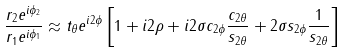Convert formula to latex. <formula><loc_0><loc_0><loc_500><loc_500>\frac { r _ { 2 } e ^ { i \phi _ { 2 } } } { r _ { 1 } e ^ { i \phi _ { 1 } } } \approx t _ { \theta } e ^ { i 2 \phi } \left [ 1 + i 2 \rho + i 2 \sigma c _ { 2 \phi } \frac { c _ { 2 \theta } } { s _ { 2 \theta } } + 2 \sigma s _ { 2 \phi } \frac { 1 } { s _ { 2 \theta } } \right ]</formula> 